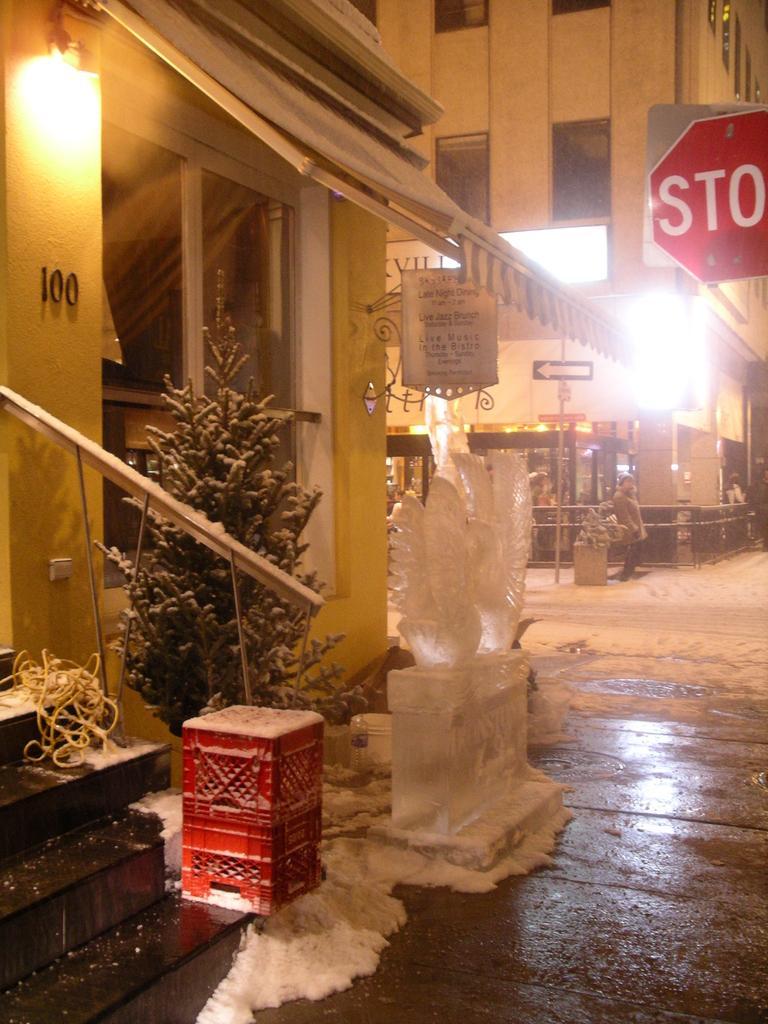Could you give a brief overview of what you see in this image? In this image there are buildings and in front of that there is a tree and box, also there is a sculpture of birds. 